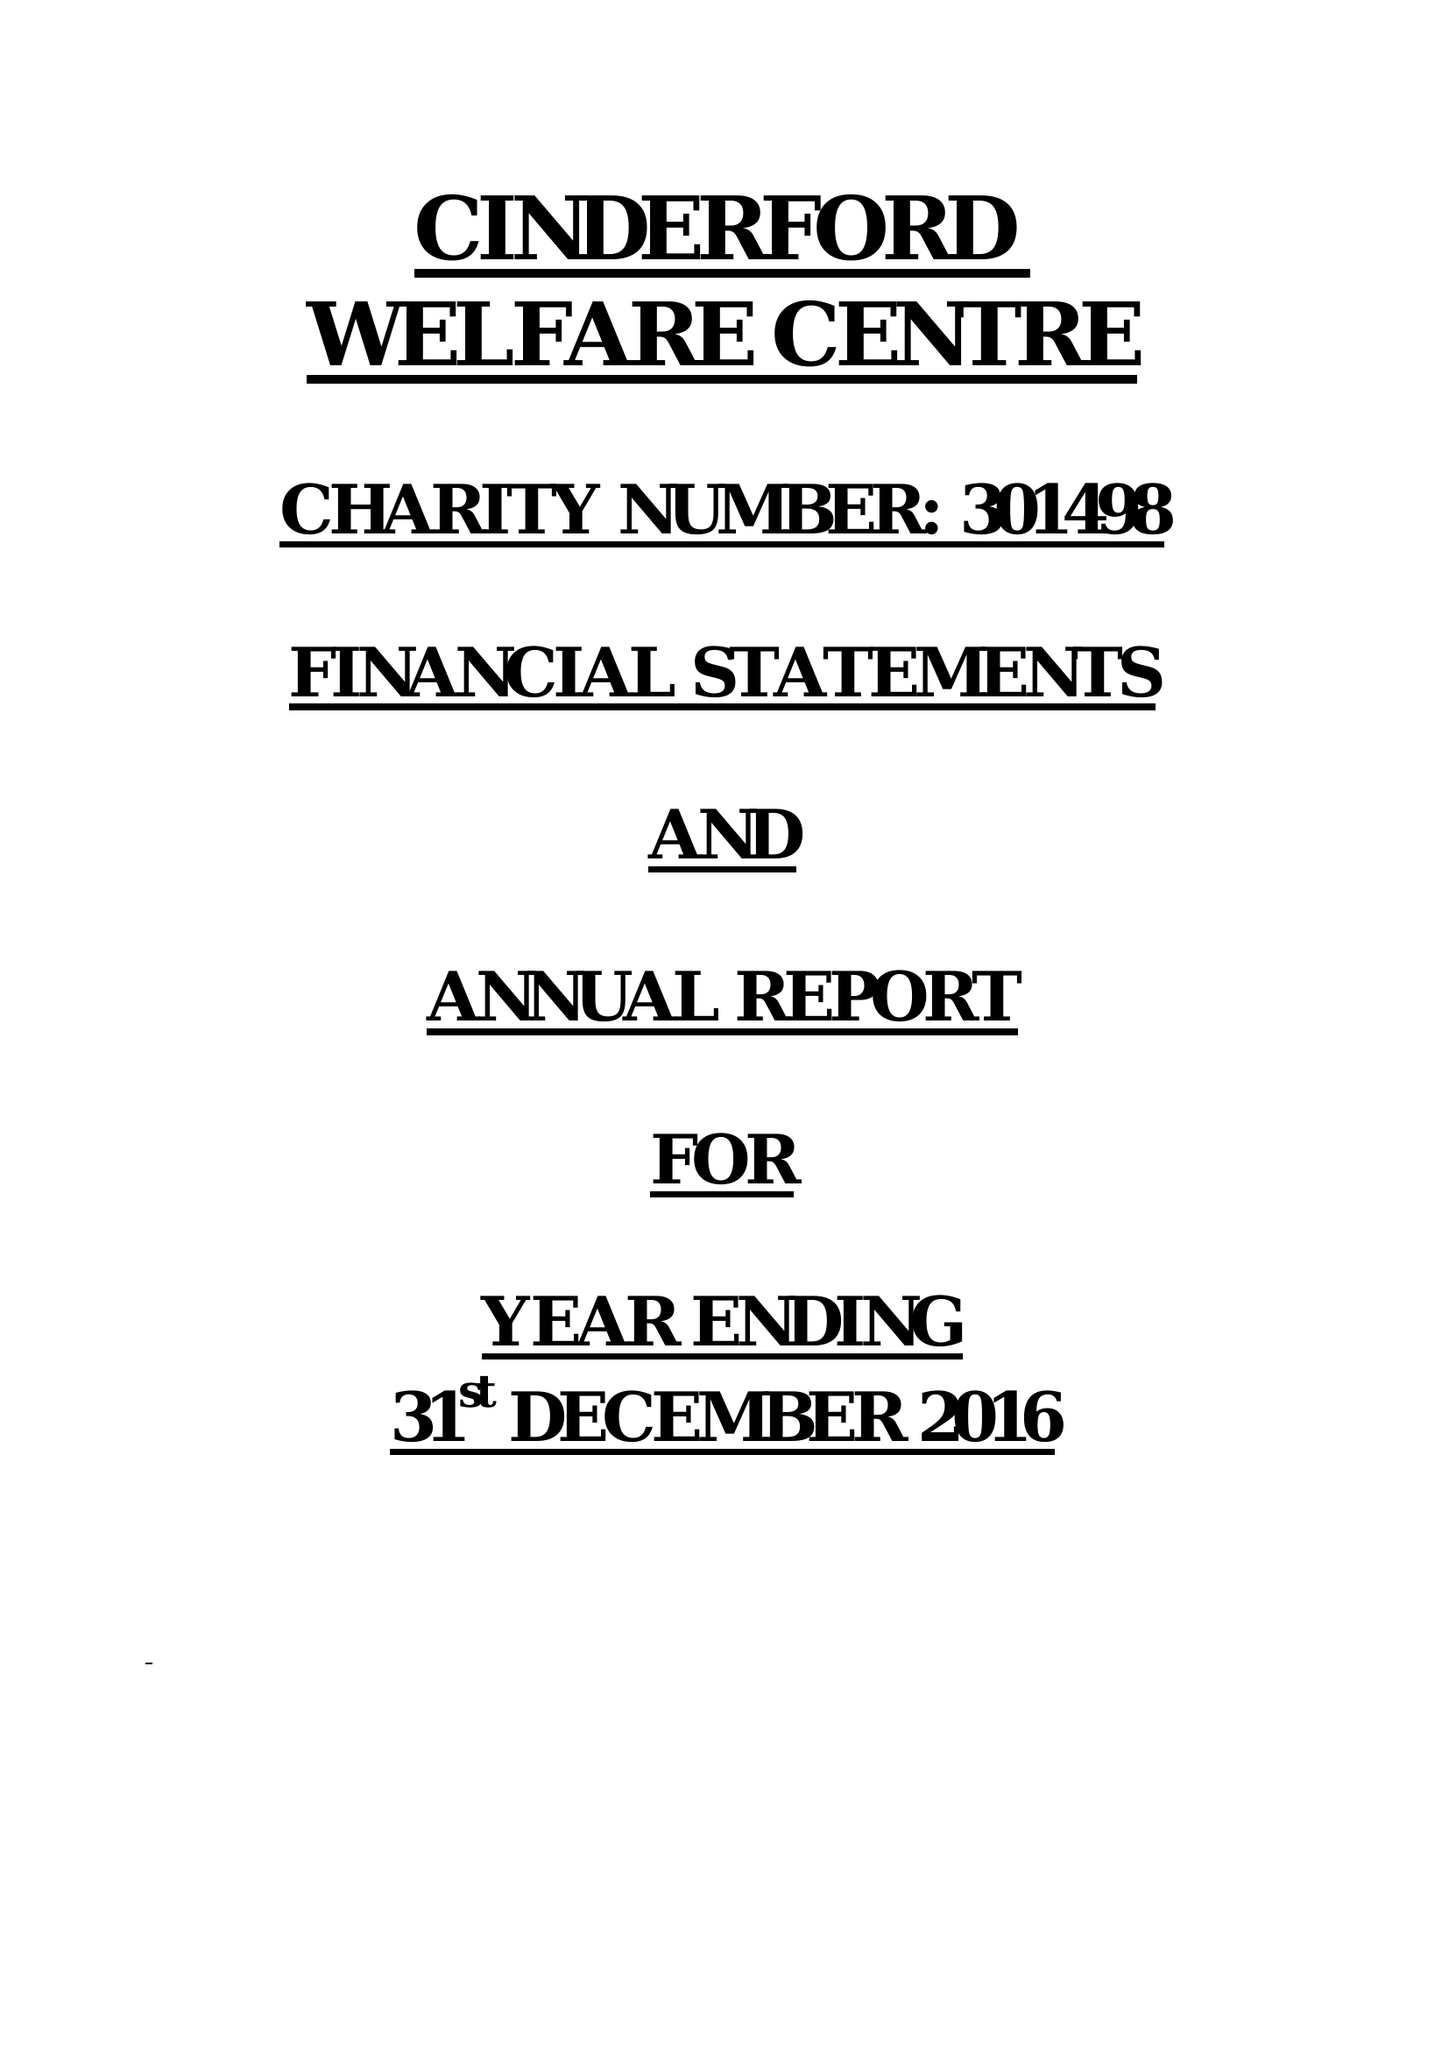What is the value for the address__postcode?
Answer the question using a single word or phrase. GL14 2JN 